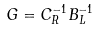Convert formula to latex. <formula><loc_0><loc_0><loc_500><loc_500>G = C _ { R } ^ { - 1 } B _ { L } ^ { - 1 }</formula> 